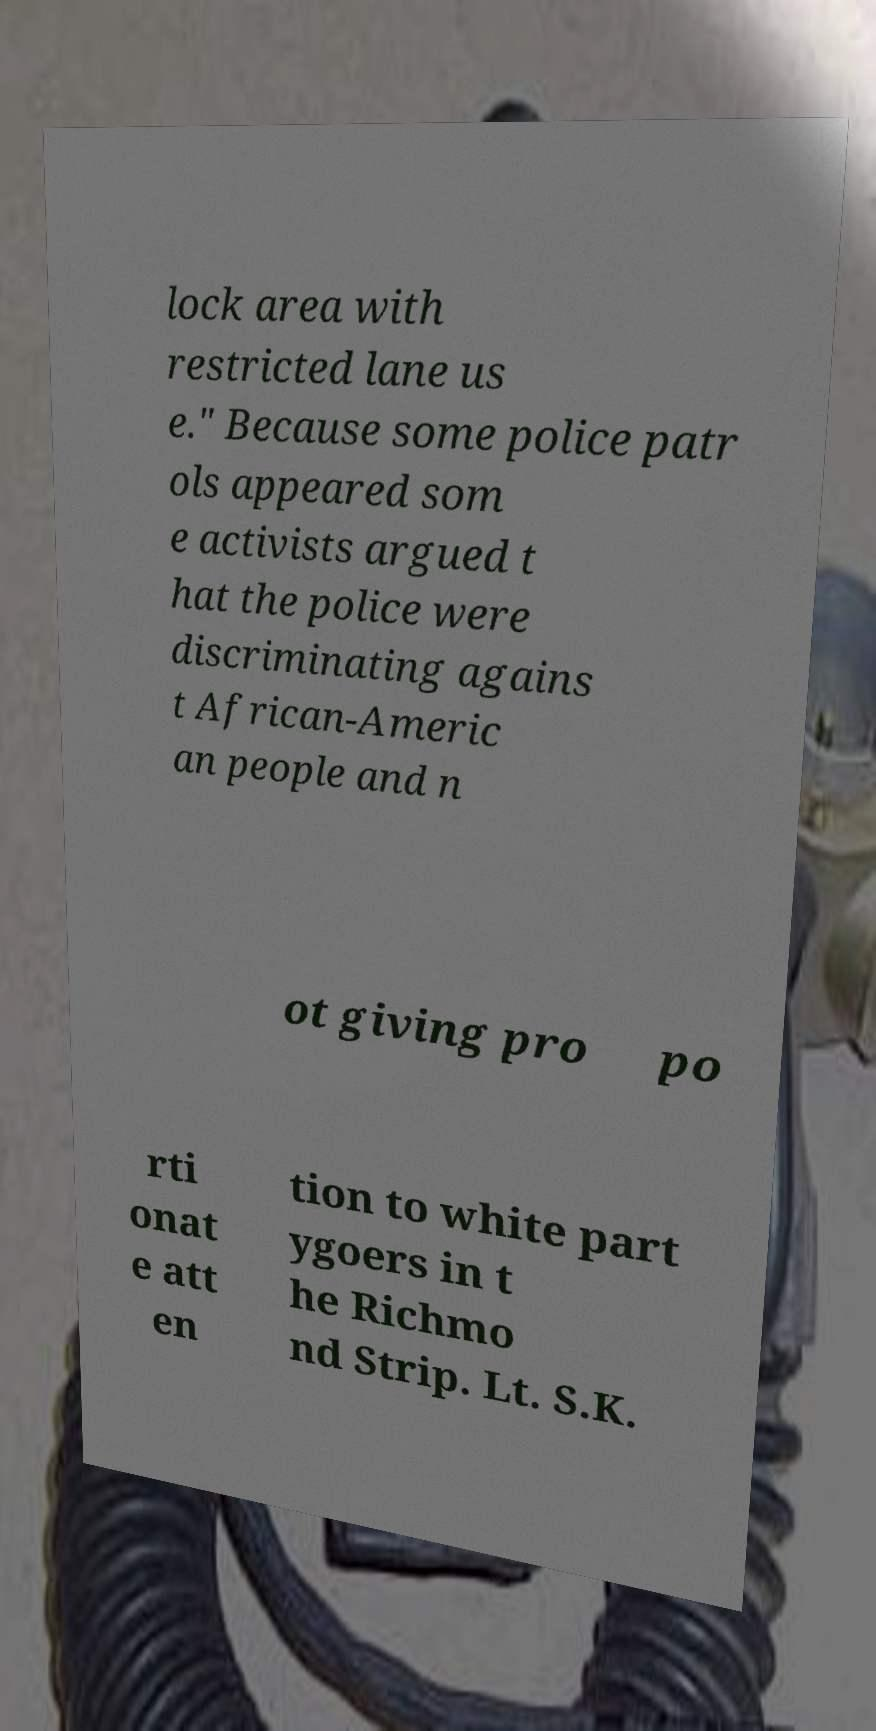For documentation purposes, I need the text within this image transcribed. Could you provide that? lock area with restricted lane us e." Because some police patr ols appeared som e activists argued t hat the police were discriminating agains t African-Americ an people and n ot giving pro po rti onat e att en tion to white part ygoers in t he Richmo nd Strip. Lt. S.K. 